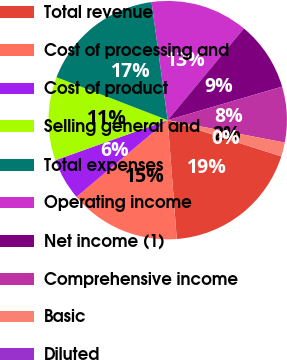<chart> <loc_0><loc_0><loc_500><loc_500><pie_chart><fcel>Total revenue<fcel>Cost of processing and<fcel>Cost of product<fcel>Selling general and<fcel>Total expenses<fcel>Operating income<fcel>Net income (1)<fcel>Comprehensive income<fcel>Basic<fcel>Diluted<nl><fcel>18.86%<fcel>15.09%<fcel>5.67%<fcel>11.32%<fcel>16.97%<fcel>13.2%<fcel>9.43%<fcel>7.55%<fcel>1.9%<fcel>0.01%<nl></chart> 